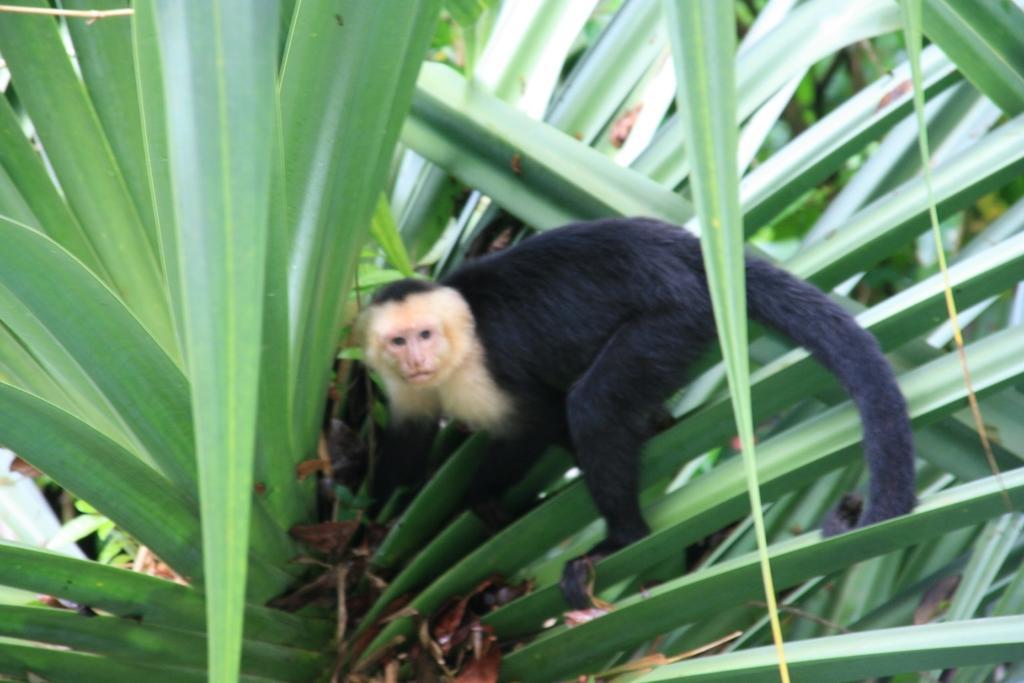Describe this image in one or two sentences. In this picture we can see there is a white-headed Capuchin on the plant. 